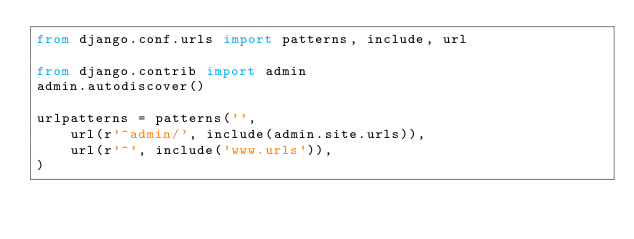Convert code to text. <code><loc_0><loc_0><loc_500><loc_500><_Python_>from django.conf.urls import patterns, include, url

from django.contrib import admin
admin.autodiscover()

urlpatterns = patterns('',
    url(r'^admin/', include(admin.site.urls)),
    url(r'^', include('www.urls')),
)
</code> 